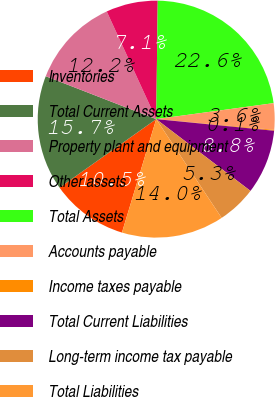<chart> <loc_0><loc_0><loc_500><loc_500><pie_chart><fcel>Inventories<fcel>Total Current Assets<fcel>Property plant and equipment<fcel>Other assets<fcel>Total Assets<fcel>Accounts payable<fcel>Income taxes payable<fcel>Total Current Liabilities<fcel>Long-term income tax payable<fcel>Total Liabilities<nl><fcel>10.52%<fcel>15.71%<fcel>12.25%<fcel>7.06%<fcel>22.64%<fcel>3.59%<fcel>0.13%<fcel>8.79%<fcel>5.33%<fcel>13.98%<nl></chart> 